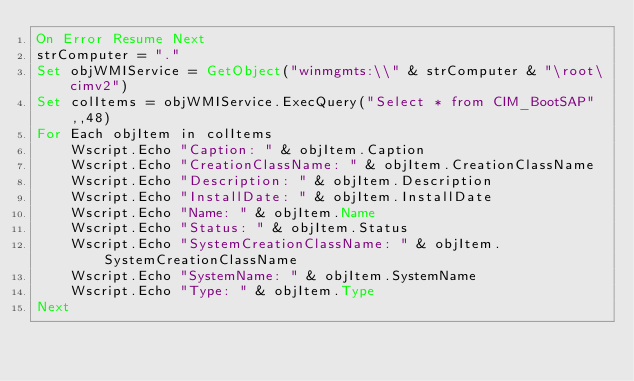<code> <loc_0><loc_0><loc_500><loc_500><_VisualBasic_>On Error Resume Next
strComputer = "."
Set objWMIService = GetObject("winmgmts:\\" & strComputer & "\root\cimv2")
Set colItems = objWMIService.ExecQuery("Select * from CIM_BootSAP",,48)
For Each objItem in colItems
    Wscript.Echo "Caption: " & objItem.Caption
    Wscript.Echo "CreationClassName: " & objItem.CreationClassName
    Wscript.Echo "Description: " & objItem.Description
    Wscript.Echo "InstallDate: " & objItem.InstallDate
    Wscript.Echo "Name: " & objItem.Name
    Wscript.Echo "Status: " & objItem.Status
    Wscript.Echo "SystemCreationClassName: " & objItem.SystemCreationClassName
    Wscript.Echo "SystemName: " & objItem.SystemName
    Wscript.Echo "Type: " & objItem.Type
Next

</code> 